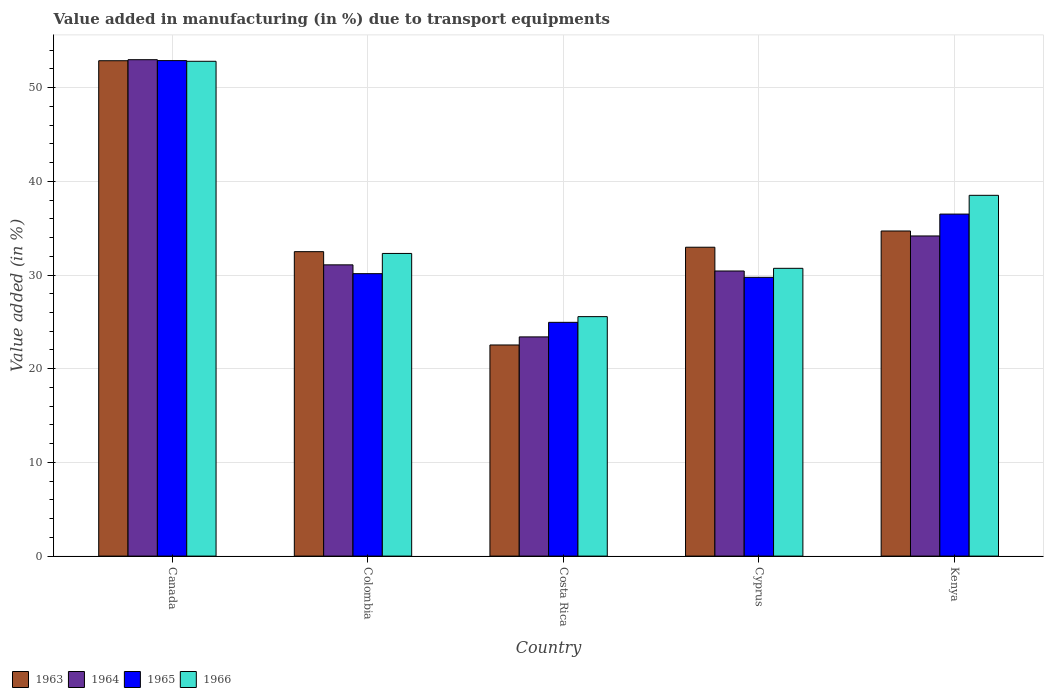Are the number of bars per tick equal to the number of legend labels?
Ensure brevity in your answer.  Yes. How many bars are there on the 4th tick from the right?
Provide a succinct answer. 4. What is the percentage of value added in manufacturing due to transport equipments in 1964 in Canada?
Offer a terse response. 52.98. Across all countries, what is the maximum percentage of value added in manufacturing due to transport equipments in 1965?
Provide a succinct answer. 52.89. Across all countries, what is the minimum percentage of value added in manufacturing due to transport equipments in 1965?
Offer a terse response. 24.95. In which country was the percentage of value added in manufacturing due to transport equipments in 1966 minimum?
Give a very brief answer. Costa Rica. What is the total percentage of value added in manufacturing due to transport equipments in 1964 in the graph?
Give a very brief answer. 172.06. What is the difference between the percentage of value added in manufacturing due to transport equipments in 1966 in Canada and that in Cyprus?
Offer a very short reply. 22.1. What is the difference between the percentage of value added in manufacturing due to transport equipments in 1963 in Colombia and the percentage of value added in manufacturing due to transport equipments in 1965 in Costa Rica?
Keep it short and to the point. 7.54. What is the average percentage of value added in manufacturing due to transport equipments in 1965 per country?
Your response must be concise. 34.85. What is the difference between the percentage of value added in manufacturing due to transport equipments of/in 1965 and percentage of value added in manufacturing due to transport equipments of/in 1966 in Cyprus?
Your answer should be very brief. -0.96. What is the ratio of the percentage of value added in manufacturing due to transport equipments in 1966 in Cyprus to that in Kenya?
Your answer should be compact. 0.8. Is the percentage of value added in manufacturing due to transport equipments in 1965 in Canada less than that in Cyprus?
Ensure brevity in your answer.  No. What is the difference between the highest and the second highest percentage of value added in manufacturing due to transport equipments in 1963?
Make the answer very short. -1.73. What is the difference between the highest and the lowest percentage of value added in manufacturing due to transport equipments in 1966?
Make the answer very short. 27.25. In how many countries, is the percentage of value added in manufacturing due to transport equipments in 1966 greater than the average percentage of value added in manufacturing due to transport equipments in 1966 taken over all countries?
Offer a very short reply. 2. Is it the case that in every country, the sum of the percentage of value added in manufacturing due to transport equipments in 1966 and percentage of value added in manufacturing due to transport equipments in 1964 is greater than the sum of percentage of value added in manufacturing due to transport equipments in 1965 and percentage of value added in manufacturing due to transport equipments in 1963?
Your response must be concise. No. What does the 3rd bar from the left in Cyprus represents?
Keep it short and to the point. 1965. What does the 1st bar from the right in Kenya represents?
Ensure brevity in your answer.  1966. How many bars are there?
Ensure brevity in your answer.  20. How many countries are there in the graph?
Keep it short and to the point. 5. Does the graph contain grids?
Make the answer very short. Yes. How many legend labels are there?
Provide a succinct answer. 4. What is the title of the graph?
Give a very brief answer. Value added in manufacturing (in %) due to transport equipments. What is the label or title of the X-axis?
Offer a terse response. Country. What is the label or title of the Y-axis?
Provide a succinct answer. Value added (in %). What is the Value added (in %) of 1963 in Canada?
Provide a short and direct response. 52.87. What is the Value added (in %) of 1964 in Canada?
Ensure brevity in your answer.  52.98. What is the Value added (in %) in 1965 in Canada?
Provide a succinct answer. 52.89. What is the Value added (in %) in 1966 in Canada?
Provide a short and direct response. 52.81. What is the Value added (in %) in 1963 in Colombia?
Your answer should be compact. 32.49. What is the Value added (in %) of 1964 in Colombia?
Ensure brevity in your answer.  31.09. What is the Value added (in %) of 1965 in Colombia?
Offer a terse response. 30.15. What is the Value added (in %) of 1966 in Colombia?
Provide a short and direct response. 32.3. What is the Value added (in %) in 1963 in Costa Rica?
Offer a terse response. 22.53. What is the Value added (in %) of 1964 in Costa Rica?
Your answer should be very brief. 23.4. What is the Value added (in %) in 1965 in Costa Rica?
Ensure brevity in your answer.  24.95. What is the Value added (in %) in 1966 in Costa Rica?
Give a very brief answer. 25.56. What is the Value added (in %) of 1963 in Cyprus?
Give a very brief answer. 32.97. What is the Value added (in %) of 1964 in Cyprus?
Provide a succinct answer. 30.43. What is the Value added (in %) in 1965 in Cyprus?
Keep it short and to the point. 29.75. What is the Value added (in %) in 1966 in Cyprus?
Offer a terse response. 30.72. What is the Value added (in %) of 1963 in Kenya?
Your response must be concise. 34.7. What is the Value added (in %) of 1964 in Kenya?
Offer a very short reply. 34.17. What is the Value added (in %) of 1965 in Kenya?
Provide a short and direct response. 36.5. What is the Value added (in %) in 1966 in Kenya?
Give a very brief answer. 38.51. Across all countries, what is the maximum Value added (in %) of 1963?
Your response must be concise. 52.87. Across all countries, what is the maximum Value added (in %) in 1964?
Your answer should be compact. 52.98. Across all countries, what is the maximum Value added (in %) in 1965?
Your response must be concise. 52.89. Across all countries, what is the maximum Value added (in %) of 1966?
Your answer should be compact. 52.81. Across all countries, what is the minimum Value added (in %) in 1963?
Offer a terse response. 22.53. Across all countries, what is the minimum Value added (in %) of 1964?
Ensure brevity in your answer.  23.4. Across all countries, what is the minimum Value added (in %) of 1965?
Keep it short and to the point. 24.95. Across all countries, what is the minimum Value added (in %) of 1966?
Give a very brief answer. 25.56. What is the total Value added (in %) in 1963 in the graph?
Provide a succinct answer. 175.57. What is the total Value added (in %) of 1964 in the graph?
Your response must be concise. 172.06. What is the total Value added (in %) of 1965 in the graph?
Provide a succinct answer. 174.24. What is the total Value added (in %) in 1966 in the graph?
Provide a short and direct response. 179.9. What is the difference between the Value added (in %) in 1963 in Canada and that in Colombia?
Ensure brevity in your answer.  20.38. What is the difference between the Value added (in %) of 1964 in Canada and that in Colombia?
Provide a short and direct response. 21.9. What is the difference between the Value added (in %) of 1965 in Canada and that in Colombia?
Provide a succinct answer. 22.74. What is the difference between the Value added (in %) in 1966 in Canada and that in Colombia?
Your answer should be very brief. 20.51. What is the difference between the Value added (in %) of 1963 in Canada and that in Costa Rica?
Your answer should be very brief. 30.34. What is the difference between the Value added (in %) of 1964 in Canada and that in Costa Rica?
Provide a succinct answer. 29.59. What is the difference between the Value added (in %) in 1965 in Canada and that in Costa Rica?
Your response must be concise. 27.93. What is the difference between the Value added (in %) in 1966 in Canada and that in Costa Rica?
Ensure brevity in your answer.  27.25. What is the difference between the Value added (in %) in 1963 in Canada and that in Cyprus?
Your answer should be compact. 19.91. What is the difference between the Value added (in %) of 1964 in Canada and that in Cyprus?
Your response must be concise. 22.55. What is the difference between the Value added (in %) in 1965 in Canada and that in Cyprus?
Provide a succinct answer. 23.13. What is the difference between the Value added (in %) of 1966 in Canada and that in Cyprus?
Make the answer very short. 22.1. What is the difference between the Value added (in %) of 1963 in Canada and that in Kenya?
Make the answer very short. 18.17. What is the difference between the Value added (in %) of 1964 in Canada and that in Kenya?
Ensure brevity in your answer.  18.81. What is the difference between the Value added (in %) of 1965 in Canada and that in Kenya?
Your response must be concise. 16.38. What is the difference between the Value added (in %) of 1966 in Canada and that in Kenya?
Provide a succinct answer. 14.3. What is the difference between the Value added (in %) in 1963 in Colombia and that in Costa Rica?
Keep it short and to the point. 9.96. What is the difference between the Value added (in %) of 1964 in Colombia and that in Costa Rica?
Ensure brevity in your answer.  7.69. What is the difference between the Value added (in %) in 1965 in Colombia and that in Costa Rica?
Your answer should be compact. 5.2. What is the difference between the Value added (in %) in 1966 in Colombia and that in Costa Rica?
Ensure brevity in your answer.  6.74. What is the difference between the Value added (in %) of 1963 in Colombia and that in Cyprus?
Your response must be concise. -0.47. What is the difference between the Value added (in %) in 1964 in Colombia and that in Cyprus?
Offer a terse response. 0.66. What is the difference between the Value added (in %) of 1965 in Colombia and that in Cyprus?
Ensure brevity in your answer.  0.39. What is the difference between the Value added (in %) in 1966 in Colombia and that in Cyprus?
Offer a very short reply. 1.59. What is the difference between the Value added (in %) of 1963 in Colombia and that in Kenya?
Make the answer very short. -2.21. What is the difference between the Value added (in %) in 1964 in Colombia and that in Kenya?
Ensure brevity in your answer.  -3.08. What is the difference between the Value added (in %) of 1965 in Colombia and that in Kenya?
Ensure brevity in your answer.  -6.36. What is the difference between the Value added (in %) in 1966 in Colombia and that in Kenya?
Make the answer very short. -6.2. What is the difference between the Value added (in %) of 1963 in Costa Rica and that in Cyprus?
Provide a short and direct response. -10.43. What is the difference between the Value added (in %) in 1964 in Costa Rica and that in Cyprus?
Ensure brevity in your answer.  -7.03. What is the difference between the Value added (in %) in 1965 in Costa Rica and that in Cyprus?
Provide a short and direct response. -4.8. What is the difference between the Value added (in %) in 1966 in Costa Rica and that in Cyprus?
Make the answer very short. -5.16. What is the difference between the Value added (in %) in 1963 in Costa Rica and that in Kenya?
Keep it short and to the point. -12.17. What is the difference between the Value added (in %) in 1964 in Costa Rica and that in Kenya?
Ensure brevity in your answer.  -10.77. What is the difference between the Value added (in %) of 1965 in Costa Rica and that in Kenya?
Offer a terse response. -11.55. What is the difference between the Value added (in %) of 1966 in Costa Rica and that in Kenya?
Offer a very short reply. -12.95. What is the difference between the Value added (in %) of 1963 in Cyprus and that in Kenya?
Offer a terse response. -1.73. What is the difference between the Value added (in %) of 1964 in Cyprus and that in Kenya?
Give a very brief answer. -3.74. What is the difference between the Value added (in %) in 1965 in Cyprus and that in Kenya?
Offer a very short reply. -6.75. What is the difference between the Value added (in %) in 1966 in Cyprus and that in Kenya?
Provide a short and direct response. -7.79. What is the difference between the Value added (in %) in 1963 in Canada and the Value added (in %) in 1964 in Colombia?
Offer a very short reply. 21.79. What is the difference between the Value added (in %) in 1963 in Canada and the Value added (in %) in 1965 in Colombia?
Ensure brevity in your answer.  22.73. What is the difference between the Value added (in %) of 1963 in Canada and the Value added (in %) of 1966 in Colombia?
Your answer should be very brief. 20.57. What is the difference between the Value added (in %) of 1964 in Canada and the Value added (in %) of 1965 in Colombia?
Provide a short and direct response. 22.84. What is the difference between the Value added (in %) in 1964 in Canada and the Value added (in %) in 1966 in Colombia?
Keep it short and to the point. 20.68. What is the difference between the Value added (in %) in 1965 in Canada and the Value added (in %) in 1966 in Colombia?
Provide a succinct answer. 20.58. What is the difference between the Value added (in %) of 1963 in Canada and the Value added (in %) of 1964 in Costa Rica?
Offer a very short reply. 29.48. What is the difference between the Value added (in %) of 1963 in Canada and the Value added (in %) of 1965 in Costa Rica?
Your answer should be compact. 27.92. What is the difference between the Value added (in %) in 1963 in Canada and the Value added (in %) in 1966 in Costa Rica?
Keep it short and to the point. 27.31. What is the difference between the Value added (in %) in 1964 in Canada and the Value added (in %) in 1965 in Costa Rica?
Provide a short and direct response. 28.03. What is the difference between the Value added (in %) of 1964 in Canada and the Value added (in %) of 1966 in Costa Rica?
Your response must be concise. 27.42. What is the difference between the Value added (in %) of 1965 in Canada and the Value added (in %) of 1966 in Costa Rica?
Your answer should be very brief. 27.33. What is the difference between the Value added (in %) in 1963 in Canada and the Value added (in %) in 1964 in Cyprus?
Give a very brief answer. 22.44. What is the difference between the Value added (in %) in 1963 in Canada and the Value added (in %) in 1965 in Cyprus?
Keep it short and to the point. 23.12. What is the difference between the Value added (in %) in 1963 in Canada and the Value added (in %) in 1966 in Cyprus?
Ensure brevity in your answer.  22.16. What is the difference between the Value added (in %) in 1964 in Canada and the Value added (in %) in 1965 in Cyprus?
Make the answer very short. 23.23. What is the difference between the Value added (in %) of 1964 in Canada and the Value added (in %) of 1966 in Cyprus?
Make the answer very short. 22.27. What is the difference between the Value added (in %) of 1965 in Canada and the Value added (in %) of 1966 in Cyprus?
Give a very brief answer. 22.17. What is the difference between the Value added (in %) in 1963 in Canada and the Value added (in %) in 1964 in Kenya?
Offer a very short reply. 18.7. What is the difference between the Value added (in %) in 1963 in Canada and the Value added (in %) in 1965 in Kenya?
Provide a succinct answer. 16.37. What is the difference between the Value added (in %) in 1963 in Canada and the Value added (in %) in 1966 in Kenya?
Offer a very short reply. 14.37. What is the difference between the Value added (in %) of 1964 in Canada and the Value added (in %) of 1965 in Kenya?
Your answer should be compact. 16.48. What is the difference between the Value added (in %) of 1964 in Canada and the Value added (in %) of 1966 in Kenya?
Offer a very short reply. 14.47. What is the difference between the Value added (in %) of 1965 in Canada and the Value added (in %) of 1966 in Kenya?
Give a very brief answer. 14.38. What is the difference between the Value added (in %) of 1963 in Colombia and the Value added (in %) of 1964 in Costa Rica?
Keep it short and to the point. 9.1. What is the difference between the Value added (in %) in 1963 in Colombia and the Value added (in %) in 1965 in Costa Rica?
Ensure brevity in your answer.  7.54. What is the difference between the Value added (in %) of 1963 in Colombia and the Value added (in %) of 1966 in Costa Rica?
Make the answer very short. 6.93. What is the difference between the Value added (in %) of 1964 in Colombia and the Value added (in %) of 1965 in Costa Rica?
Give a very brief answer. 6.14. What is the difference between the Value added (in %) of 1964 in Colombia and the Value added (in %) of 1966 in Costa Rica?
Make the answer very short. 5.53. What is the difference between the Value added (in %) in 1965 in Colombia and the Value added (in %) in 1966 in Costa Rica?
Give a very brief answer. 4.59. What is the difference between the Value added (in %) in 1963 in Colombia and the Value added (in %) in 1964 in Cyprus?
Offer a terse response. 2.06. What is the difference between the Value added (in %) in 1963 in Colombia and the Value added (in %) in 1965 in Cyprus?
Your answer should be very brief. 2.74. What is the difference between the Value added (in %) in 1963 in Colombia and the Value added (in %) in 1966 in Cyprus?
Offer a very short reply. 1.78. What is the difference between the Value added (in %) in 1964 in Colombia and the Value added (in %) in 1965 in Cyprus?
Give a very brief answer. 1.33. What is the difference between the Value added (in %) of 1964 in Colombia and the Value added (in %) of 1966 in Cyprus?
Your answer should be very brief. 0.37. What is the difference between the Value added (in %) in 1965 in Colombia and the Value added (in %) in 1966 in Cyprus?
Provide a short and direct response. -0.57. What is the difference between the Value added (in %) in 1963 in Colombia and the Value added (in %) in 1964 in Kenya?
Offer a terse response. -1.68. What is the difference between the Value added (in %) of 1963 in Colombia and the Value added (in %) of 1965 in Kenya?
Give a very brief answer. -4.01. What is the difference between the Value added (in %) of 1963 in Colombia and the Value added (in %) of 1966 in Kenya?
Keep it short and to the point. -6.01. What is the difference between the Value added (in %) of 1964 in Colombia and the Value added (in %) of 1965 in Kenya?
Your response must be concise. -5.42. What is the difference between the Value added (in %) in 1964 in Colombia and the Value added (in %) in 1966 in Kenya?
Give a very brief answer. -7.42. What is the difference between the Value added (in %) in 1965 in Colombia and the Value added (in %) in 1966 in Kenya?
Give a very brief answer. -8.36. What is the difference between the Value added (in %) of 1963 in Costa Rica and the Value added (in %) of 1964 in Cyprus?
Keep it short and to the point. -7.9. What is the difference between the Value added (in %) in 1963 in Costa Rica and the Value added (in %) in 1965 in Cyprus?
Your answer should be very brief. -7.22. What is the difference between the Value added (in %) in 1963 in Costa Rica and the Value added (in %) in 1966 in Cyprus?
Give a very brief answer. -8.18. What is the difference between the Value added (in %) of 1964 in Costa Rica and the Value added (in %) of 1965 in Cyprus?
Provide a short and direct response. -6.36. What is the difference between the Value added (in %) of 1964 in Costa Rica and the Value added (in %) of 1966 in Cyprus?
Your response must be concise. -7.32. What is the difference between the Value added (in %) in 1965 in Costa Rica and the Value added (in %) in 1966 in Cyprus?
Give a very brief answer. -5.77. What is the difference between the Value added (in %) of 1963 in Costa Rica and the Value added (in %) of 1964 in Kenya?
Your response must be concise. -11.64. What is the difference between the Value added (in %) in 1963 in Costa Rica and the Value added (in %) in 1965 in Kenya?
Make the answer very short. -13.97. What is the difference between the Value added (in %) of 1963 in Costa Rica and the Value added (in %) of 1966 in Kenya?
Provide a short and direct response. -15.97. What is the difference between the Value added (in %) in 1964 in Costa Rica and the Value added (in %) in 1965 in Kenya?
Offer a very short reply. -13.11. What is the difference between the Value added (in %) in 1964 in Costa Rica and the Value added (in %) in 1966 in Kenya?
Keep it short and to the point. -15.11. What is the difference between the Value added (in %) of 1965 in Costa Rica and the Value added (in %) of 1966 in Kenya?
Your response must be concise. -13.56. What is the difference between the Value added (in %) of 1963 in Cyprus and the Value added (in %) of 1964 in Kenya?
Ensure brevity in your answer.  -1.2. What is the difference between the Value added (in %) of 1963 in Cyprus and the Value added (in %) of 1965 in Kenya?
Ensure brevity in your answer.  -3.54. What is the difference between the Value added (in %) in 1963 in Cyprus and the Value added (in %) in 1966 in Kenya?
Offer a terse response. -5.54. What is the difference between the Value added (in %) in 1964 in Cyprus and the Value added (in %) in 1965 in Kenya?
Your response must be concise. -6.07. What is the difference between the Value added (in %) of 1964 in Cyprus and the Value added (in %) of 1966 in Kenya?
Offer a very short reply. -8.08. What is the difference between the Value added (in %) in 1965 in Cyprus and the Value added (in %) in 1966 in Kenya?
Your answer should be very brief. -8.75. What is the average Value added (in %) in 1963 per country?
Provide a short and direct response. 35.11. What is the average Value added (in %) of 1964 per country?
Your response must be concise. 34.41. What is the average Value added (in %) of 1965 per country?
Give a very brief answer. 34.85. What is the average Value added (in %) in 1966 per country?
Make the answer very short. 35.98. What is the difference between the Value added (in %) in 1963 and Value added (in %) in 1964 in Canada?
Offer a terse response. -0.11. What is the difference between the Value added (in %) of 1963 and Value added (in %) of 1965 in Canada?
Your answer should be very brief. -0.01. What is the difference between the Value added (in %) in 1963 and Value added (in %) in 1966 in Canada?
Make the answer very short. 0.06. What is the difference between the Value added (in %) of 1964 and Value added (in %) of 1965 in Canada?
Keep it short and to the point. 0.1. What is the difference between the Value added (in %) in 1964 and Value added (in %) in 1966 in Canada?
Give a very brief answer. 0.17. What is the difference between the Value added (in %) in 1965 and Value added (in %) in 1966 in Canada?
Offer a terse response. 0.07. What is the difference between the Value added (in %) in 1963 and Value added (in %) in 1964 in Colombia?
Your answer should be very brief. 1.41. What is the difference between the Value added (in %) in 1963 and Value added (in %) in 1965 in Colombia?
Your answer should be very brief. 2.35. What is the difference between the Value added (in %) in 1963 and Value added (in %) in 1966 in Colombia?
Offer a very short reply. 0.19. What is the difference between the Value added (in %) of 1964 and Value added (in %) of 1965 in Colombia?
Make the answer very short. 0.94. What is the difference between the Value added (in %) in 1964 and Value added (in %) in 1966 in Colombia?
Make the answer very short. -1.22. What is the difference between the Value added (in %) in 1965 and Value added (in %) in 1966 in Colombia?
Offer a terse response. -2.16. What is the difference between the Value added (in %) in 1963 and Value added (in %) in 1964 in Costa Rica?
Your response must be concise. -0.86. What is the difference between the Value added (in %) of 1963 and Value added (in %) of 1965 in Costa Rica?
Your response must be concise. -2.42. What is the difference between the Value added (in %) of 1963 and Value added (in %) of 1966 in Costa Rica?
Your answer should be compact. -3.03. What is the difference between the Value added (in %) in 1964 and Value added (in %) in 1965 in Costa Rica?
Your answer should be very brief. -1.55. What is the difference between the Value added (in %) in 1964 and Value added (in %) in 1966 in Costa Rica?
Give a very brief answer. -2.16. What is the difference between the Value added (in %) in 1965 and Value added (in %) in 1966 in Costa Rica?
Provide a succinct answer. -0.61. What is the difference between the Value added (in %) in 1963 and Value added (in %) in 1964 in Cyprus?
Your answer should be very brief. 2.54. What is the difference between the Value added (in %) of 1963 and Value added (in %) of 1965 in Cyprus?
Make the answer very short. 3.21. What is the difference between the Value added (in %) in 1963 and Value added (in %) in 1966 in Cyprus?
Your answer should be compact. 2.25. What is the difference between the Value added (in %) in 1964 and Value added (in %) in 1965 in Cyprus?
Provide a short and direct response. 0.68. What is the difference between the Value added (in %) of 1964 and Value added (in %) of 1966 in Cyprus?
Your answer should be very brief. -0.29. What is the difference between the Value added (in %) of 1965 and Value added (in %) of 1966 in Cyprus?
Keep it short and to the point. -0.96. What is the difference between the Value added (in %) of 1963 and Value added (in %) of 1964 in Kenya?
Keep it short and to the point. 0.53. What is the difference between the Value added (in %) of 1963 and Value added (in %) of 1965 in Kenya?
Keep it short and to the point. -1.8. What is the difference between the Value added (in %) in 1963 and Value added (in %) in 1966 in Kenya?
Keep it short and to the point. -3.81. What is the difference between the Value added (in %) in 1964 and Value added (in %) in 1965 in Kenya?
Provide a succinct answer. -2.33. What is the difference between the Value added (in %) of 1964 and Value added (in %) of 1966 in Kenya?
Give a very brief answer. -4.34. What is the difference between the Value added (in %) in 1965 and Value added (in %) in 1966 in Kenya?
Your answer should be very brief. -2. What is the ratio of the Value added (in %) of 1963 in Canada to that in Colombia?
Ensure brevity in your answer.  1.63. What is the ratio of the Value added (in %) in 1964 in Canada to that in Colombia?
Keep it short and to the point. 1.7. What is the ratio of the Value added (in %) of 1965 in Canada to that in Colombia?
Your answer should be compact. 1.75. What is the ratio of the Value added (in %) of 1966 in Canada to that in Colombia?
Your response must be concise. 1.63. What is the ratio of the Value added (in %) of 1963 in Canada to that in Costa Rica?
Your response must be concise. 2.35. What is the ratio of the Value added (in %) of 1964 in Canada to that in Costa Rica?
Provide a succinct answer. 2.26. What is the ratio of the Value added (in %) of 1965 in Canada to that in Costa Rica?
Ensure brevity in your answer.  2.12. What is the ratio of the Value added (in %) in 1966 in Canada to that in Costa Rica?
Your answer should be compact. 2.07. What is the ratio of the Value added (in %) of 1963 in Canada to that in Cyprus?
Your response must be concise. 1.6. What is the ratio of the Value added (in %) of 1964 in Canada to that in Cyprus?
Provide a short and direct response. 1.74. What is the ratio of the Value added (in %) of 1965 in Canada to that in Cyprus?
Ensure brevity in your answer.  1.78. What is the ratio of the Value added (in %) of 1966 in Canada to that in Cyprus?
Your response must be concise. 1.72. What is the ratio of the Value added (in %) of 1963 in Canada to that in Kenya?
Offer a terse response. 1.52. What is the ratio of the Value added (in %) of 1964 in Canada to that in Kenya?
Offer a terse response. 1.55. What is the ratio of the Value added (in %) in 1965 in Canada to that in Kenya?
Offer a terse response. 1.45. What is the ratio of the Value added (in %) in 1966 in Canada to that in Kenya?
Your answer should be very brief. 1.37. What is the ratio of the Value added (in %) of 1963 in Colombia to that in Costa Rica?
Offer a terse response. 1.44. What is the ratio of the Value added (in %) of 1964 in Colombia to that in Costa Rica?
Make the answer very short. 1.33. What is the ratio of the Value added (in %) of 1965 in Colombia to that in Costa Rica?
Make the answer very short. 1.21. What is the ratio of the Value added (in %) in 1966 in Colombia to that in Costa Rica?
Offer a very short reply. 1.26. What is the ratio of the Value added (in %) in 1963 in Colombia to that in Cyprus?
Provide a succinct answer. 0.99. What is the ratio of the Value added (in %) in 1964 in Colombia to that in Cyprus?
Your answer should be compact. 1.02. What is the ratio of the Value added (in %) in 1965 in Colombia to that in Cyprus?
Offer a very short reply. 1.01. What is the ratio of the Value added (in %) in 1966 in Colombia to that in Cyprus?
Your response must be concise. 1.05. What is the ratio of the Value added (in %) in 1963 in Colombia to that in Kenya?
Provide a short and direct response. 0.94. What is the ratio of the Value added (in %) in 1964 in Colombia to that in Kenya?
Offer a very short reply. 0.91. What is the ratio of the Value added (in %) in 1965 in Colombia to that in Kenya?
Provide a succinct answer. 0.83. What is the ratio of the Value added (in %) of 1966 in Colombia to that in Kenya?
Offer a very short reply. 0.84. What is the ratio of the Value added (in %) in 1963 in Costa Rica to that in Cyprus?
Offer a terse response. 0.68. What is the ratio of the Value added (in %) of 1964 in Costa Rica to that in Cyprus?
Give a very brief answer. 0.77. What is the ratio of the Value added (in %) in 1965 in Costa Rica to that in Cyprus?
Ensure brevity in your answer.  0.84. What is the ratio of the Value added (in %) of 1966 in Costa Rica to that in Cyprus?
Offer a very short reply. 0.83. What is the ratio of the Value added (in %) in 1963 in Costa Rica to that in Kenya?
Provide a succinct answer. 0.65. What is the ratio of the Value added (in %) in 1964 in Costa Rica to that in Kenya?
Provide a short and direct response. 0.68. What is the ratio of the Value added (in %) in 1965 in Costa Rica to that in Kenya?
Provide a succinct answer. 0.68. What is the ratio of the Value added (in %) of 1966 in Costa Rica to that in Kenya?
Ensure brevity in your answer.  0.66. What is the ratio of the Value added (in %) of 1963 in Cyprus to that in Kenya?
Give a very brief answer. 0.95. What is the ratio of the Value added (in %) of 1964 in Cyprus to that in Kenya?
Provide a short and direct response. 0.89. What is the ratio of the Value added (in %) of 1965 in Cyprus to that in Kenya?
Give a very brief answer. 0.82. What is the ratio of the Value added (in %) of 1966 in Cyprus to that in Kenya?
Offer a terse response. 0.8. What is the difference between the highest and the second highest Value added (in %) of 1963?
Give a very brief answer. 18.17. What is the difference between the highest and the second highest Value added (in %) in 1964?
Your response must be concise. 18.81. What is the difference between the highest and the second highest Value added (in %) of 1965?
Give a very brief answer. 16.38. What is the difference between the highest and the second highest Value added (in %) of 1966?
Your answer should be compact. 14.3. What is the difference between the highest and the lowest Value added (in %) of 1963?
Your response must be concise. 30.34. What is the difference between the highest and the lowest Value added (in %) in 1964?
Provide a short and direct response. 29.59. What is the difference between the highest and the lowest Value added (in %) of 1965?
Offer a very short reply. 27.93. What is the difference between the highest and the lowest Value added (in %) of 1966?
Your answer should be very brief. 27.25. 